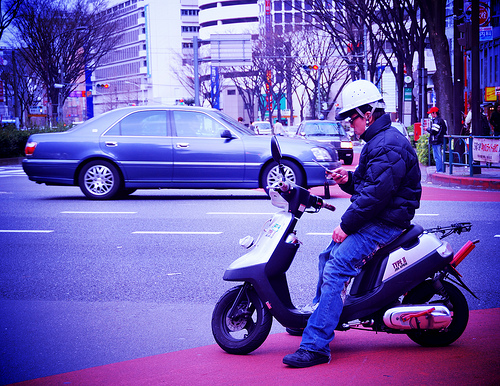What is the person doing on the scooter? The person appears to be sitting on the scooter and is likely checking their phone or a device before starting their journey. 